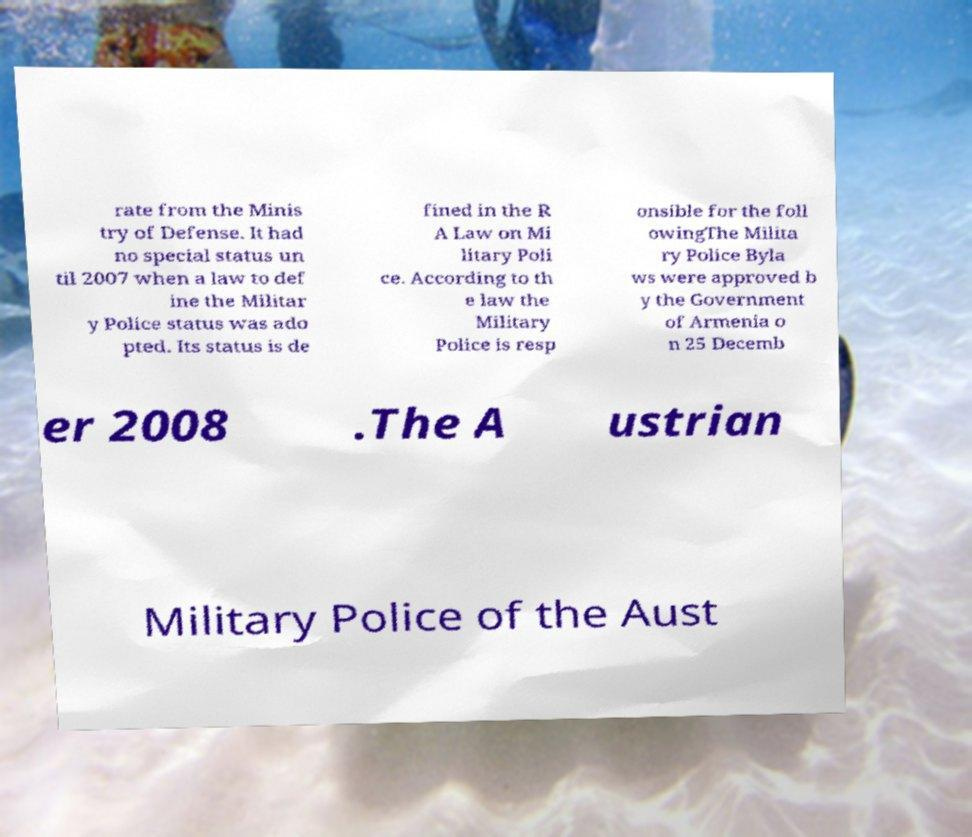Can you accurately transcribe the text from the provided image for me? rate from the Minis try of Defense. It had no special status un til 2007 when a law to def ine the Militar y Police status was ado pted. Its status is de fined in the R A Law on Mi litary Poli ce. According to th e law the Military Police is resp onsible for the foll owingThe Milita ry Police Byla ws were approved b y the Government of Armenia o n 25 Decemb er 2008 .The A ustrian Military Police of the Aust 